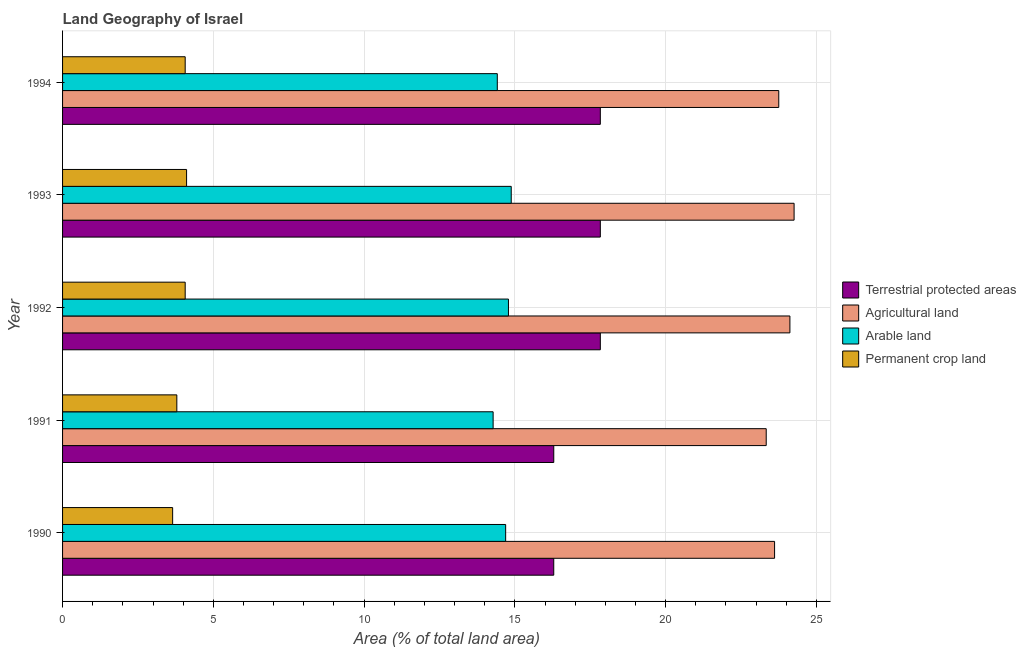How many different coloured bars are there?
Offer a terse response. 4. Are the number of bars per tick equal to the number of legend labels?
Your response must be concise. Yes. Are the number of bars on each tick of the Y-axis equal?
Your response must be concise. Yes. How many bars are there on the 4th tick from the top?
Offer a terse response. 4. What is the label of the 1st group of bars from the top?
Provide a short and direct response. 1994. What is the percentage of land under terrestrial protection in 1993?
Provide a short and direct response. 17.83. Across all years, what is the maximum percentage of area under arable land?
Make the answer very short. 14.88. Across all years, what is the minimum percentage of area under agricultural land?
Provide a short and direct response. 23.34. In which year was the percentage of area under permanent crop land maximum?
Give a very brief answer. 1993. What is the total percentage of area under arable land in the graph?
Offer a terse response. 73.06. What is the difference between the percentage of area under agricultural land in 1991 and that in 1994?
Keep it short and to the point. -0.42. What is the difference between the percentage of area under agricultural land in 1993 and the percentage of land under terrestrial protection in 1992?
Your response must be concise. 6.43. What is the average percentage of area under agricultural land per year?
Ensure brevity in your answer.  23.82. In the year 1992, what is the difference between the percentage of area under agricultural land and percentage of area under arable land?
Your answer should be compact. 9.34. In how many years, is the percentage of area under arable land greater than 10 %?
Your answer should be compact. 5. Is the difference between the percentage of area under arable land in 1991 and 1994 greater than the difference between the percentage of area under permanent crop land in 1991 and 1994?
Make the answer very short. Yes. What is the difference between the highest and the second highest percentage of area under arable land?
Provide a short and direct response. 0.09. What is the difference between the highest and the lowest percentage of land under terrestrial protection?
Your answer should be compact. 1.54. Is it the case that in every year, the sum of the percentage of area under permanent crop land and percentage of area under agricultural land is greater than the sum of percentage of land under terrestrial protection and percentage of area under arable land?
Ensure brevity in your answer.  Yes. What does the 3rd bar from the top in 1991 represents?
Give a very brief answer. Agricultural land. What does the 3rd bar from the bottom in 1993 represents?
Make the answer very short. Arable land. Are all the bars in the graph horizontal?
Your response must be concise. Yes. How many years are there in the graph?
Keep it short and to the point. 5. Are the values on the major ticks of X-axis written in scientific E-notation?
Give a very brief answer. No. Where does the legend appear in the graph?
Offer a very short reply. Center right. What is the title of the graph?
Provide a succinct answer. Land Geography of Israel. Does "Revenue mobilization" appear as one of the legend labels in the graph?
Your answer should be very brief. No. What is the label or title of the X-axis?
Your answer should be compact. Area (% of total land area). What is the Area (% of total land area) of Terrestrial protected areas in 1990?
Ensure brevity in your answer.  16.29. What is the Area (% of total land area) of Agricultural land in 1990?
Offer a terse response. 23.61. What is the Area (% of total land area) of Arable land in 1990?
Provide a succinct answer. 14.7. What is the Area (% of total land area) in Permanent crop land in 1990?
Keep it short and to the point. 3.65. What is the Area (% of total land area) of Terrestrial protected areas in 1991?
Provide a succinct answer. 16.29. What is the Area (% of total land area) in Agricultural land in 1991?
Keep it short and to the point. 23.34. What is the Area (% of total land area) of Arable land in 1991?
Make the answer very short. 14.28. What is the Area (% of total land area) in Permanent crop land in 1991?
Make the answer very short. 3.79. What is the Area (% of total land area) in Terrestrial protected areas in 1992?
Provide a short and direct response. 17.83. What is the Area (% of total land area) in Agricultural land in 1992?
Provide a short and direct response. 24.12. What is the Area (% of total land area) in Arable land in 1992?
Provide a short and direct response. 14.79. What is the Area (% of total land area) in Permanent crop land in 1992?
Make the answer very short. 4.07. What is the Area (% of total land area) of Terrestrial protected areas in 1993?
Your answer should be very brief. 17.83. What is the Area (% of total land area) of Agricultural land in 1993?
Give a very brief answer. 24.26. What is the Area (% of total land area) in Arable land in 1993?
Your response must be concise. 14.88. What is the Area (% of total land area) of Permanent crop land in 1993?
Your response must be concise. 4.11. What is the Area (% of total land area) in Terrestrial protected areas in 1994?
Make the answer very short. 17.83. What is the Area (% of total land area) in Agricultural land in 1994?
Offer a terse response. 23.75. What is the Area (% of total land area) of Arable land in 1994?
Give a very brief answer. 14.42. What is the Area (% of total land area) in Permanent crop land in 1994?
Provide a succinct answer. 4.07. Across all years, what is the maximum Area (% of total land area) in Terrestrial protected areas?
Offer a very short reply. 17.83. Across all years, what is the maximum Area (% of total land area) of Agricultural land?
Keep it short and to the point. 24.26. Across all years, what is the maximum Area (% of total land area) in Arable land?
Offer a very short reply. 14.88. Across all years, what is the maximum Area (% of total land area) in Permanent crop land?
Your response must be concise. 4.11. Across all years, what is the minimum Area (% of total land area) of Terrestrial protected areas?
Provide a succinct answer. 16.29. Across all years, what is the minimum Area (% of total land area) in Agricultural land?
Keep it short and to the point. 23.34. Across all years, what is the minimum Area (% of total land area) of Arable land?
Your answer should be very brief. 14.28. Across all years, what is the minimum Area (% of total land area) in Permanent crop land?
Provide a short and direct response. 3.65. What is the total Area (% of total land area) of Terrestrial protected areas in the graph?
Make the answer very short. 86.08. What is the total Area (% of total land area) of Agricultural land in the graph?
Offer a terse response. 119.08. What is the total Area (% of total land area) of Arable land in the graph?
Ensure brevity in your answer.  73.06. What is the total Area (% of total land area) in Permanent crop land in the graph?
Offer a very short reply. 19.69. What is the difference between the Area (% of total land area) in Terrestrial protected areas in 1990 and that in 1991?
Ensure brevity in your answer.  -0. What is the difference between the Area (% of total land area) of Agricultural land in 1990 and that in 1991?
Give a very brief answer. 0.28. What is the difference between the Area (% of total land area) in Arable land in 1990 and that in 1991?
Offer a terse response. 0.42. What is the difference between the Area (% of total land area) in Permanent crop land in 1990 and that in 1991?
Your answer should be very brief. -0.14. What is the difference between the Area (% of total land area) in Terrestrial protected areas in 1990 and that in 1992?
Give a very brief answer. -1.54. What is the difference between the Area (% of total land area) in Agricultural land in 1990 and that in 1992?
Provide a succinct answer. -0.51. What is the difference between the Area (% of total land area) of Arable land in 1990 and that in 1992?
Offer a terse response. -0.09. What is the difference between the Area (% of total land area) in Permanent crop land in 1990 and that in 1992?
Your response must be concise. -0.42. What is the difference between the Area (% of total land area) of Terrestrial protected areas in 1990 and that in 1993?
Your answer should be compact. -1.54. What is the difference between the Area (% of total land area) in Agricultural land in 1990 and that in 1993?
Give a very brief answer. -0.65. What is the difference between the Area (% of total land area) in Arable land in 1990 and that in 1993?
Your answer should be very brief. -0.18. What is the difference between the Area (% of total land area) of Permanent crop land in 1990 and that in 1993?
Give a very brief answer. -0.46. What is the difference between the Area (% of total land area) in Terrestrial protected areas in 1990 and that in 1994?
Give a very brief answer. -1.54. What is the difference between the Area (% of total land area) in Agricultural land in 1990 and that in 1994?
Your response must be concise. -0.14. What is the difference between the Area (% of total land area) of Arable land in 1990 and that in 1994?
Your response must be concise. 0.28. What is the difference between the Area (% of total land area) in Permanent crop land in 1990 and that in 1994?
Keep it short and to the point. -0.42. What is the difference between the Area (% of total land area) in Terrestrial protected areas in 1991 and that in 1992?
Make the answer very short. -1.54. What is the difference between the Area (% of total land area) in Agricultural land in 1991 and that in 1992?
Give a very brief answer. -0.79. What is the difference between the Area (% of total land area) in Arable land in 1991 and that in 1992?
Provide a succinct answer. -0.51. What is the difference between the Area (% of total land area) in Permanent crop land in 1991 and that in 1992?
Offer a terse response. -0.28. What is the difference between the Area (% of total land area) of Terrestrial protected areas in 1991 and that in 1993?
Ensure brevity in your answer.  -1.54. What is the difference between the Area (% of total land area) in Agricultural land in 1991 and that in 1993?
Your answer should be very brief. -0.92. What is the difference between the Area (% of total land area) of Arable land in 1991 and that in 1993?
Give a very brief answer. -0.6. What is the difference between the Area (% of total land area) in Permanent crop land in 1991 and that in 1993?
Provide a short and direct response. -0.32. What is the difference between the Area (% of total land area) of Terrestrial protected areas in 1991 and that in 1994?
Offer a terse response. -1.54. What is the difference between the Area (% of total land area) in Agricultural land in 1991 and that in 1994?
Offer a terse response. -0.42. What is the difference between the Area (% of total land area) in Arable land in 1991 and that in 1994?
Offer a very short reply. -0.14. What is the difference between the Area (% of total land area) of Permanent crop land in 1991 and that in 1994?
Keep it short and to the point. -0.28. What is the difference between the Area (% of total land area) in Agricultural land in 1992 and that in 1993?
Your answer should be compact. -0.14. What is the difference between the Area (% of total land area) in Arable land in 1992 and that in 1993?
Offer a terse response. -0.09. What is the difference between the Area (% of total land area) of Permanent crop land in 1992 and that in 1993?
Your response must be concise. -0.05. What is the difference between the Area (% of total land area) of Terrestrial protected areas in 1992 and that in 1994?
Ensure brevity in your answer.  0. What is the difference between the Area (% of total land area) in Agricultural land in 1992 and that in 1994?
Ensure brevity in your answer.  0.37. What is the difference between the Area (% of total land area) of Arable land in 1992 and that in 1994?
Ensure brevity in your answer.  0.37. What is the difference between the Area (% of total land area) in Permanent crop land in 1992 and that in 1994?
Make the answer very short. 0. What is the difference between the Area (% of total land area) in Agricultural land in 1993 and that in 1994?
Ensure brevity in your answer.  0.51. What is the difference between the Area (% of total land area) of Arable land in 1993 and that in 1994?
Your answer should be very brief. 0.46. What is the difference between the Area (% of total land area) in Permanent crop land in 1993 and that in 1994?
Offer a very short reply. 0.05. What is the difference between the Area (% of total land area) of Terrestrial protected areas in 1990 and the Area (% of total land area) of Agricultural land in 1991?
Provide a short and direct response. -7.05. What is the difference between the Area (% of total land area) in Terrestrial protected areas in 1990 and the Area (% of total land area) in Arable land in 1991?
Give a very brief answer. 2.01. What is the difference between the Area (% of total land area) of Terrestrial protected areas in 1990 and the Area (% of total land area) of Permanent crop land in 1991?
Ensure brevity in your answer.  12.5. What is the difference between the Area (% of total land area) of Agricultural land in 1990 and the Area (% of total land area) of Arable land in 1991?
Offer a terse response. 9.33. What is the difference between the Area (% of total land area) in Agricultural land in 1990 and the Area (% of total land area) in Permanent crop land in 1991?
Ensure brevity in your answer.  19.82. What is the difference between the Area (% of total land area) in Arable land in 1990 and the Area (% of total land area) in Permanent crop land in 1991?
Your answer should be very brief. 10.91. What is the difference between the Area (% of total land area) of Terrestrial protected areas in 1990 and the Area (% of total land area) of Agricultural land in 1992?
Ensure brevity in your answer.  -7.83. What is the difference between the Area (% of total land area) in Terrestrial protected areas in 1990 and the Area (% of total land area) in Arable land in 1992?
Ensure brevity in your answer.  1.5. What is the difference between the Area (% of total land area) of Terrestrial protected areas in 1990 and the Area (% of total land area) of Permanent crop land in 1992?
Ensure brevity in your answer.  12.22. What is the difference between the Area (% of total land area) of Agricultural land in 1990 and the Area (% of total land area) of Arable land in 1992?
Offer a very short reply. 8.83. What is the difference between the Area (% of total land area) of Agricultural land in 1990 and the Area (% of total land area) of Permanent crop land in 1992?
Offer a very short reply. 19.55. What is the difference between the Area (% of total land area) of Arable land in 1990 and the Area (% of total land area) of Permanent crop land in 1992?
Offer a terse response. 10.63. What is the difference between the Area (% of total land area) of Terrestrial protected areas in 1990 and the Area (% of total land area) of Agricultural land in 1993?
Your answer should be very brief. -7.97. What is the difference between the Area (% of total land area) of Terrestrial protected areas in 1990 and the Area (% of total land area) of Arable land in 1993?
Your answer should be very brief. 1.41. What is the difference between the Area (% of total land area) of Terrestrial protected areas in 1990 and the Area (% of total land area) of Permanent crop land in 1993?
Give a very brief answer. 12.18. What is the difference between the Area (% of total land area) of Agricultural land in 1990 and the Area (% of total land area) of Arable land in 1993?
Give a very brief answer. 8.73. What is the difference between the Area (% of total land area) of Agricultural land in 1990 and the Area (% of total land area) of Permanent crop land in 1993?
Keep it short and to the point. 19.5. What is the difference between the Area (% of total land area) in Arable land in 1990 and the Area (% of total land area) in Permanent crop land in 1993?
Offer a very short reply. 10.58. What is the difference between the Area (% of total land area) of Terrestrial protected areas in 1990 and the Area (% of total land area) of Agricultural land in 1994?
Your response must be concise. -7.46. What is the difference between the Area (% of total land area) in Terrestrial protected areas in 1990 and the Area (% of total land area) in Arable land in 1994?
Offer a very short reply. 1.87. What is the difference between the Area (% of total land area) of Terrestrial protected areas in 1990 and the Area (% of total land area) of Permanent crop land in 1994?
Make the answer very short. 12.22. What is the difference between the Area (% of total land area) of Agricultural land in 1990 and the Area (% of total land area) of Arable land in 1994?
Your answer should be compact. 9.2. What is the difference between the Area (% of total land area) in Agricultural land in 1990 and the Area (% of total land area) in Permanent crop land in 1994?
Your response must be concise. 19.55. What is the difference between the Area (% of total land area) of Arable land in 1990 and the Area (% of total land area) of Permanent crop land in 1994?
Ensure brevity in your answer.  10.63. What is the difference between the Area (% of total land area) in Terrestrial protected areas in 1991 and the Area (% of total land area) in Agricultural land in 1992?
Provide a short and direct response. -7.83. What is the difference between the Area (% of total land area) in Terrestrial protected areas in 1991 and the Area (% of total land area) in Arable land in 1992?
Provide a succinct answer. 1.5. What is the difference between the Area (% of total land area) of Terrestrial protected areas in 1991 and the Area (% of total land area) of Permanent crop land in 1992?
Provide a short and direct response. 12.22. What is the difference between the Area (% of total land area) in Agricultural land in 1991 and the Area (% of total land area) in Arable land in 1992?
Your answer should be compact. 8.55. What is the difference between the Area (% of total land area) of Agricultural land in 1991 and the Area (% of total land area) of Permanent crop land in 1992?
Your answer should be compact. 19.27. What is the difference between the Area (% of total land area) in Arable land in 1991 and the Area (% of total land area) in Permanent crop land in 1992?
Ensure brevity in your answer.  10.21. What is the difference between the Area (% of total land area) in Terrestrial protected areas in 1991 and the Area (% of total land area) in Agricultural land in 1993?
Give a very brief answer. -7.97. What is the difference between the Area (% of total land area) of Terrestrial protected areas in 1991 and the Area (% of total land area) of Arable land in 1993?
Your answer should be very brief. 1.41. What is the difference between the Area (% of total land area) in Terrestrial protected areas in 1991 and the Area (% of total land area) in Permanent crop land in 1993?
Make the answer very short. 12.18. What is the difference between the Area (% of total land area) of Agricultural land in 1991 and the Area (% of total land area) of Arable land in 1993?
Give a very brief answer. 8.46. What is the difference between the Area (% of total land area) in Agricultural land in 1991 and the Area (% of total land area) in Permanent crop land in 1993?
Your answer should be compact. 19.22. What is the difference between the Area (% of total land area) of Arable land in 1991 and the Area (% of total land area) of Permanent crop land in 1993?
Your answer should be compact. 10.17. What is the difference between the Area (% of total land area) in Terrestrial protected areas in 1991 and the Area (% of total land area) in Agricultural land in 1994?
Ensure brevity in your answer.  -7.46. What is the difference between the Area (% of total land area) in Terrestrial protected areas in 1991 and the Area (% of total land area) in Arable land in 1994?
Your answer should be very brief. 1.87. What is the difference between the Area (% of total land area) in Terrestrial protected areas in 1991 and the Area (% of total land area) in Permanent crop land in 1994?
Offer a very short reply. 12.22. What is the difference between the Area (% of total land area) in Agricultural land in 1991 and the Area (% of total land area) in Arable land in 1994?
Keep it short and to the point. 8.92. What is the difference between the Area (% of total land area) of Agricultural land in 1991 and the Area (% of total land area) of Permanent crop land in 1994?
Offer a very short reply. 19.27. What is the difference between the Area (% of total land area) in Arable land in 1991 and the Area (% of total land area) in Permanent crop land in 1994?
Give a very brief answer. 10.21. What is the difference between the Area (% of total land area) in Terrestrial protected areas in 1992 and the Area (% of total land area) in Agricultural land in 1993?
Keep it short and to the point. -6.43. What is the difference between the Area (% of total land area) of Terrestrial protected areas in 1992 and the Area (% of total land area) of Arable land in 1993?
Make the answer very short. 2.95. What is the difference between the Area (% of total land area) in Terrestrial protected areas in 1992 and the Area (% of total land area) in Permanent crop land in 1993?
Your response must be concise. 13.72. What is the difference between the Area (% of total land area) in Agricultural land in 1992 and the Area (% of total land area) in Arable land in 1993?
Your answer should be very brief. 9.24. What is the difference between the Area (% of total land area) in Agricultural land in 1992 and the Area (% of total land area) in Permanent crop land in 1993?
Offer a very short reply. 20.01. What is the difference between the Area (% of total land area) of Arable land in 1992 and the Area (% of total land area) of Permanent crop land in 1993?
Make the answer very short. 10.67. What is the difference between the Area (% of total land area) of Terrestrial protected areas in 1992 and the Area (% of total land area) of Agricultural land in 1994?
Your response must be concise. -5.92. What is the difference between the Area (% of total land area) in Terrestrial protected areas in 1992 and the Area (% of total land area) in Arable land in 1994?
Provide a short and direct response. 3.42. What is the difference between the Area (% of total land area) in Terrestrial protected areas in 1992 and the Area (% of total land area) in Permanent crop land in 1994?
Offer a very short reply. 13.77. What is the difference between the Area (% of total land area) in Agricultural land in 1992 and the Area (% of total land area) in Arable land in 1994?
Provide a succinct answer. 9.7. What is the difference between the Area (% of total land area) in Agricultural land in 1992 and the Area (% of total land area) in Permanent crop land in 1994?
Keep it short and to the point. 20.06. What is the difference between the Area (% of total land area) in Arable land in 1992 and the Area (% of total land area) in Permanent crop land in 1994?
Give a very brief answer. 10.72. What is the difference between the Area (% of total land area) in Terrestrial protected areas in 1993 and the Area (% of total land area) in Agricultural land in 1994?
Your response must be concise. -5.92. What is the difference between the Area (% of total land area) in Terrestrial protected areas in 1993 and the Area (% of total land area) in Arable land in 1994?
Your answer should be very brief. 3.42. What is the difference between the Area (% of total land area) of Terrestrial protected areas in 1993 and the Area (% of total land area) of Permanent crop land in 1994?
Keep it short and to the point. 13.77. What is the difference between the Area (% of total land area) of Agricultural land in 1993 and the Area (% of total land area) of Arable land in 1994?
Keep it short and to the point. 9.84. What is the difference between the Area (% of total land area) in Agricultural land in 1993 and the Area (% of total land area) in Permanent crop land in 1994?
Keep it short and to the point. 20.19. What is the difference between the Area (% of total land area) in Arable land in 1993 and the Area (% of total land area) in Permanent crop land in 1994?
Offer a very short reply. 10.81. What is the average Area (% of total land area) of Terrestrial protected areas per year?
Provide a succinct answer. 17.22. What is the average Area (% of total land area) in Agricultural land per year?
Your response must be concise. 23.82. What is the average Area (% of total land area) in Arable land per year?
Provide a succinct answer. 14.61. What is the average Area (% of total land area) in Permanent crop land per year?
Offer a very short reply. 3.94. In the year 1990, what is the difference between the Area (% of total land area) of Terrestrial protected areas and Area (% of total land area) of Agricultural land?
Your response must be concise. -7.32. In the year 1990, what is the difference between the Area (% of total land area) in Terrestrial protected areas and Area (% of total land area) in Arable land?
Give a very brief answer. 1.59. In the year 1990, what is the difference between the Area (% of total land area) of Terrestrial protected areas and Area (% of total land area) of Permanent crop land?
Ensure brevity in your answer.  12.64. In the year 1990, what is the difference between the Area (% of total land area) in Agricultural land and Area (% of total land area) in Arable land?
Offer a very short reply. 8.92. In the year 1990, what is the difference between the Area (% of total land area) in Agricultural land and Area (% of total land area) in Permanent crop land?
Your answer should be very brief. 19.96. In the year 1990, what is the difference between the Area (% of total land area) of Arable land and Area (% of total land area) of Permanent crop land?
Your answer should be very brief. 11.04. In the year 1991, what is the difference between the Area (% of total land area) in Terrestrial protected areas and Area (% of total land area) in Agricultural land?
Offer a terse response. -7.05. In the year 1991, what is the difference between the Area (% of total land area) of Terrestrial protected areas and Area (% of total land area) of Arable land?
Your response must be concise. 2.01. In the year 1991, what is the difference between the Area (% of total land area) in Terrestrial protected areas and Area (% of total land area) in Permanent crop land?
Give a very brief answer. 12.5. In the year 1991, what is the difference between the Area (% of total land area) of Agricultural land and Area (% of total land area) of Arable land?
Your response must be concise. 9.06. In the year 1991, what is the difference between the Area (% of total land area) of Agricultural land and Area (% of total land area) of Permanent crop land?
Your answer should be compact. 19.55. In the year 1991, what is the difference between the Area (% of total land area) in Arable land and Area (% of total land area) in Permanent crop land?
Provide a short and direct response. 10.49. In the year 1992, what is the difference between the Area (% of total land area) of Terrestrial protected areas and Area (% of total land area) of Agricultural land?
Your answer should be very brief. -6.29. In the year 1992, what is the difference between the Area (% of total land area) of Terrestrial protected areas and Area (% of total land area) of Arable land?
Provide a succinct answer. 3.05. In the year 1992, what is the difference between the Area (% of total land area) in Terrestrial protected areas and Area (% of total land area) in Permanent crop land?
Provide a succinct answer. 13.77. In the year 1992, what is the difference between the Area (% of total land area) in Agricultural land and Area (% of total land area) in Arable land?
Provide a short and direct response. 9.33. In the year 1992, what is the difference between the Area (% of total land area) in Agricultural land and Area (% of total land area) in Permanent crop land?
Your answer should be very brief. 20.06. In the year 1992, what is the difference between the Area (% of total land area) of Arable land and Area (% of total land area) of Permanent crop land?
Provide a succinct answer. 10.72. In the year 1993, what is the difference between the Area (% of total land area) of Terrestrial protected areas and Area (% of total land area) of Agricultural land?
Provide a succinct answer. -6.43. In the year 1993, what is the difference between the Area (% of total land area) in Terrestrial protected areas and Area (% of total land area) in Arable land?
Your answer should be compact. 2.95. In the year 1993, what is the difference between the Area (% of total land area) in Terrestrial protected areas and Area (% of total land area) in Permanent crop land?
Your response must be concise. 13.72. In the year 1993, what is the difference between the Area (% of total land area) of Agricultural land and Area (% of total land area) of Arable land?
Keep it short and to the point. 9.38. In the year 1993, what is the difference between the Area (% of total land area) in Agricultural land and Area (% of total land area) in Permanent crop land?
Your answer should be very brief. 20.15. In the year 1993, what is the difference between the Area (% of total land area) in Arable land and Area (% of total land area) in Permanent crop land?
Offer a terse response. 10.77. In the year 1994, what is the difference between the Area (% of total land area) of Terrestrial protected areas and Area (% of total land area) of Agricultural land?
Your answer should be very brief. -5.92. In the year 1994, what is the difference between the Area (% of total land area) of Terrestrial protected areas and Area (% of total land area) of Arable land?
Provide a succinct answer. 3.42. In the year 1994, what is the difference between the Area (% of total land area) of Terrestrial protected areas and Area (% of total land area) of Permanent crop land?
Your answer should be very brief. 13.77. In the year 1994, what is the difference between the Area (% of total land area) of Agricultural land and Area (% of total land area) of Arable land?
Make the answer very short. 9.33. In the year 1994, what is the difference between the Area (% of total land area) of Agricultural land and Area (% of total land area) of Permanent crop land?
Provide a short and direct response. 19.69. In the year 1994, what is the difference between the Area (% of total land area) of Arable land and Area (% of total land area) of Permanent crop land?
Your response must be concise. 10.35. What is the ratio of the Area (% of total land area) of Agricultural land in 1990 to that in 1991?
Provide a succinct answer. 1.01. What is the ratio of the Area (% of total land area) of Arable land in 1990 to that in 1991?
Offer a very short reply. 1.03. What is the ratio of the Area (% of total land area) of Permanent crop land in 1990 to that in 1991?
Your response must be concise. 0.96. What is the ratio of the Area (% of total land area) in Terrestrial protected areas in 1990 to that in 1992?
Provide a succinct answer. 0.91. What is the ratio of the Area (% of total land area) in Agricultural land in 1990 to that in 1992?
Offer a terse response. 0.98. What is the ratio of the Area (% of total land area) of Permanent crop land in 1990 to that in 1992?
Ensure brevity in your answer.  0.9. What is the ratio of the Area (% of total land area) in Terrestrial protected areas in 1990 to that in 1993?
Provide a succinct answer. 0.91. What is the ratio of the Area (% of total land area) of Agricultural land in 1990 to that in 1993?
Your answer should be very brief. 0.97. What is the ratio of the Area (% of total land area) of Arable land in 1990 to that in 1993?
Ensure brevity in your answer.  0.99. What is the ratio of the Area (% of total land area) of Permanent crop land in 1990 to that in 1993?
Give a very brief answer. 0.89. What is the ratio of the Area (% of total land area) of Terrestrial protected areas in 1990 to that in 1994?
Your response must be concise. 0.91. What is the ratio of the Area (% of total land area) of Arable land in 1990 to that in 1994?
Give a very brief answer. 1.02. What is the ratio of the Area (% of total land area) in Permanent crop land in 1990 to that in 1994?
Your answer should be very brief. 0.9. What is the ratio of the Area (% of total land area) of Terrestrial protected areas in 1991 to that in 1992?
Ensure brevity in your answer.  0.91. What is the ratio of the Area (% of total land area) of Agricultural land in 1991 to that in 1992?
Offer a very short reply. 0.97. What is the ratio of the Area (% of total land area) of Arable land in 1991 to that in 1992?
Keep it short and to the point. 0.97. What is the ratio of the Area (% of total land area) of Permanent crop land in 1991 to that in 1992?
Your answer should be very brief. 0.93. What is the ratio of the Area (% of total land area) of Terrestrial protected areas in 1991 to that in 1993?
Provide a succinct answer. 0.91. What is the ratio of the Area (% of total land area) of Agricultural land in 1991 to that in 1993?
Ensure brevity in your answer.  0.96. What is the ratio of the Area (% of total land area) of Arable land in 1991 to that in 1993?
Make the answer very short. 0.96. What is the ratio of the Area (% of total land area) of Permanent crop land in 1991 to that in 1993?
Offer a terse response. 0.92. What is the ratio of the Area (% of total land area) of Terrestrial protected areas in 1991 to that in 1994?
Provide a short and direct response. 0.91. What is the ratio of the Area (% of total land area) of Agricultural land in 1991 to that in 1994?
Provide a succinct answer. 0.98. What is the ratio of the Area (% of total land area) in Arable land in 1991 to that in 1994?
Offer a very short reply. 0.99. What is the ratio of the Area (% of total land area) of Permanent crop land in 1991 to that in 1994?
Ensure brevity in your answer.  0.93. What is the ratio of the Area (% of total land area) of Terrestrial protected areas in 1992 to that in 1993?
Your response must be concise. 1. What is the ratio of the Area (% of total land area) of Agricultural land in 1992 to that in 1993?
Your answer should be compact. 0.99. What is the ratio of the Area (% of total land area) in Arable land in 1992 to that in 1993?
Keep it short and to the point. 0.99. What is the ratio of the Area (% of total land area) in Terrestrial protected areas in 1992 to that in 1994?
Provide a succinct answer. 1. What is the ratio of the Area (% of total land area) in Agricultural land in 1992 to that in 1994?
Keep it short and to the point. 1.02. What is the ratio of the Area (% of total land area) in Arable land in 1992 to that in 1994?
Provide a succinct answer. 1.03. What is the ratio of the Area (% of total land area) in Permanent crop land in 1992 to that in 1994?
Your response must be concise. 1. What is the ratio of the Area (% of total land area) in Terrestrial protected areas in 1993 to that in 1994?
Keep it short and to the point. 1. What is the ratio of the Area (% of total land area) in Agricultural land in 1993 to that in 1994?
Offer a terse response. 1.02. What is the ratio of the Area (% of total land area) of Arable land in 1993 to that in 1994?
Ensure brevity in your answer.  1.03. What is the ratio of the Area (% of total land area) in Permanent crop land in 1993 to that in 1994?
Give a very brief answer. 1.01. What is the difference between the highest and the second highest Area (% of total land area) in Agricultural land?
Your answer should be very brief. 0.14. What is the difference between the highest and the second highest Area (% of total land area) of Arable land?
Your answer should be compact. 0.09. What is the difference between the highest and the second highest Area (% of total land area) of Permanent crop land?
Give a very brief answer. 0.05. What is the difference between the highest and the lowest Area (% of total land area) in Terrestrial protected areas?
Provide a succinct answer. 1.54. What is the difference between the highest and the lowest Area (% of total land area) of Agricultural land?
Your answer should be very brief. 0.92. What is the difference between the highest and the lowest Area (% of total land area) of Arable land?
Your answer should be compact. 0.6. What is the difference between the highest and the lowest Area (% of total land area) of Permanent crop land?
Provide a short and direct response. 0.46. 